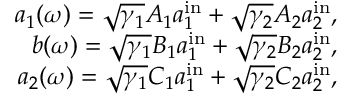Convert formula to latex. <formula><loc_0><loc_0><loc_500><loc_500>\begin{array} { r } { a _ { 1 } ( \omega ) = \sqrt { \gamma _ { 1 } } A _ { 1 } a _ { 1 } ^ { i n } + \sqrt { \gamma _ { 2 } } A _ { 2 } a _ { 2 } ^ { i n } , } \\ { b ( \omega ) = \sqrt { \gamma _ { 1 } } B _ { 1 } a _ { 1 } ^ { i n } + \sqrt { \gamma _ { 2 } } B _ { 2 } a _ { 2 } ^ { i n } , } \\ { a _ { 2 } ( \omega ) = \sqrt { \gamma _ { 1 } } C _ { 1 } a _ { 1 } ^ { i n } + \sqrt { \gamma _ { 2 } } C _ { 2 } a _ { 2 } ^ { i n } , } \end{array}</formula> 